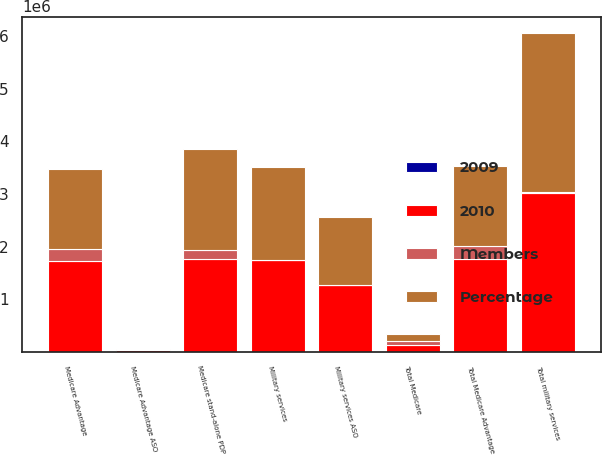Convert chart to OTSL. <chart><loc_0><loc_0><loc_500><loc_500><stacked_bar_chart><ecel><fcel>Medicare Advantage<fcel>Medicare Advantage ASO<fcel>Total Medicare Advantage<fcel>Medicare stand-alone PDP<fcel>Total Medicare<fcel>Military services<fcel>Military services ASO<fcel>Total military services<nl><fcel>2010<fcel>1.7338e+06<fcel>28200<fcel>1.762e+06<fcel>1.7588e+06<fcel>126750<fcel>1.7552e+06<fcel>1.2726e+06<fcel>3.0278e+06<nl><fcel>Percentage<fcel>1.5085e+06<fcel>0<fcel>1.5085e+06<fcel>1.9279e+06<fcel>126750<fcel>1.756e+06<fcel>1.2784e+06<fcel>3.0344e+06<nl><fcel>Members<fcel>225300<fcel>28200<fcel>253500<fcel>169100<fcel>84400<fcel>800<fcel>5800<fcel>6600<nl><fcel>2009<fcel>14.9<fcel>100<fcel>16.8<fcel>8.8<fcel>2.5<fcel>0<fcel>0.5<fcel>0.2<nl></chart> 